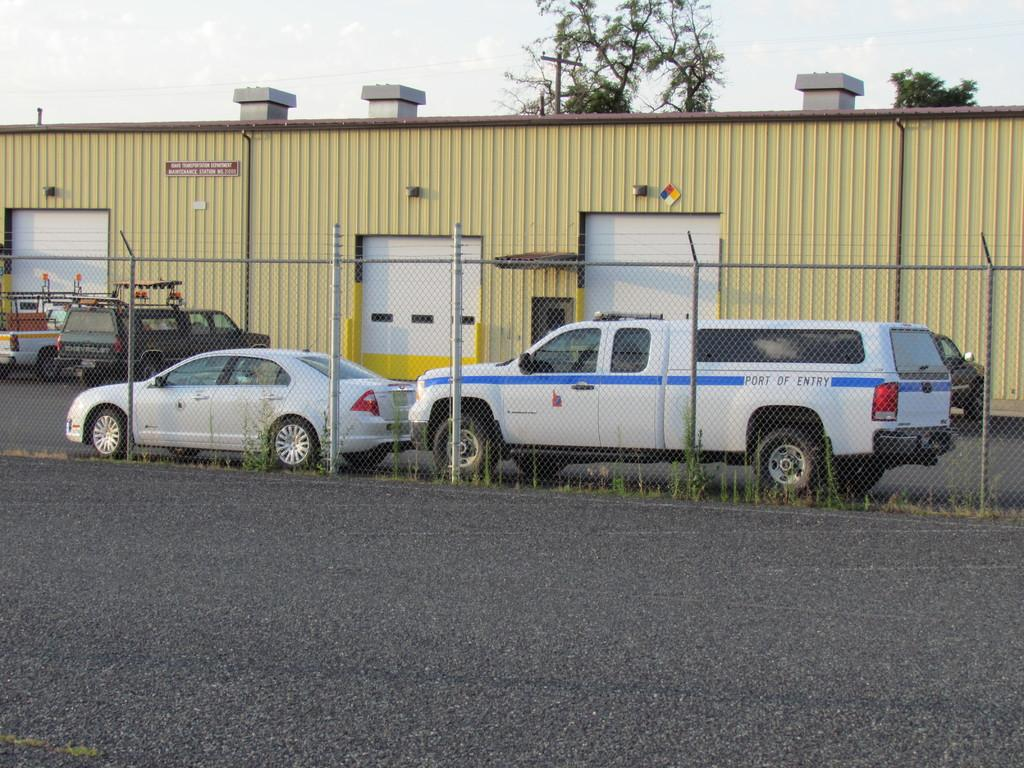What can be seen on the road in the image? There are vehicles on the road in the image. What is located on the left side of the image? There is a fence on the left side of the image. What is situated on the right side of the image? There is a shed on the right side of the image. What type of vegetation is visible behind the shed on the right side of the image? There are trees behind the shed on the right side of the image. What type of cracker is being used to water the flower in the image? There is no cracker or flower present in the image. What type of cup is being used to hold the cupcake in the image? There is no cupcake or cup present in the image. 